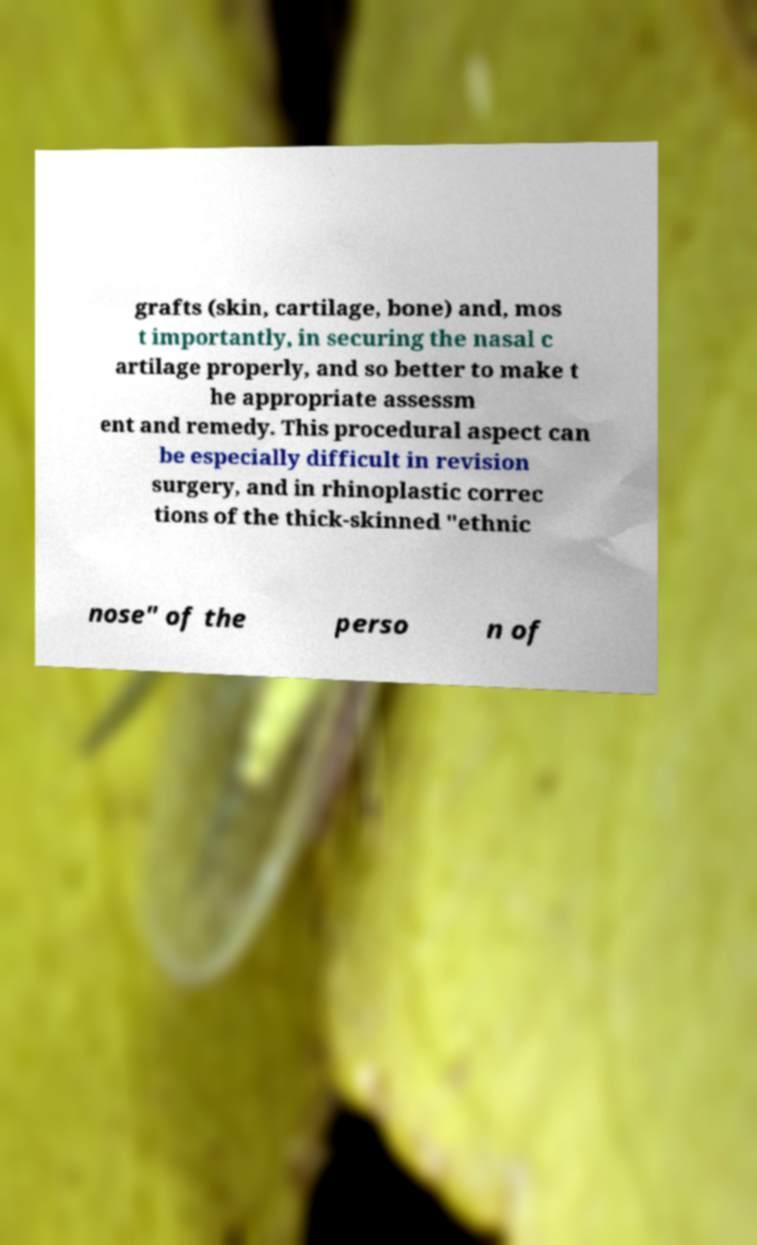Please identify and transcribe the text found in this image. grafts (skin, cartilage, bone) and, mos t importantly, in securing the nasal c artilage properly, and so better to make t he appropriate assessm ent and remedy. This procedural aspect can be especially difficult in revision surgery, and in rhinoplastic correc tions of the thick-skinned "ethnic nose" of the perso n of 